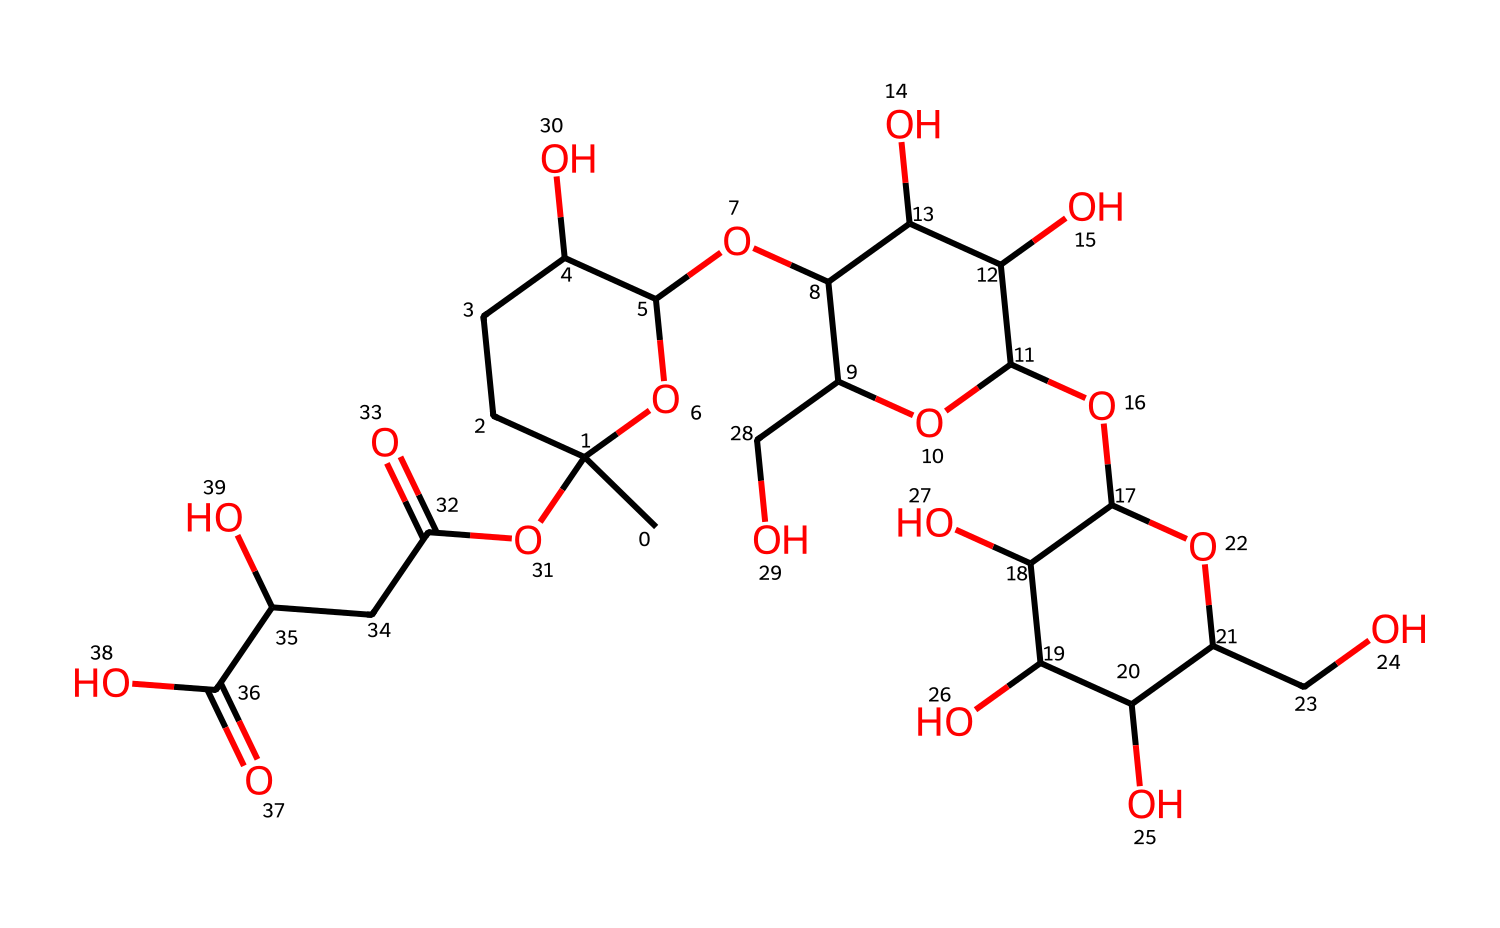What is the primary functional group present in xanthan gum? The structure of xanthan gum contains multiple hydroxyl (–OH) groups, which are indicative of its soluble and hydrophilic nature. These groups are responsible for the thickening properties of xanthan gum in gels.
Answer: hydroxyl group How many carbon atoms are in the structure of xanthan gum? By examining the SMILES representation, we can count the number of carbon atoms present. The formula indicates a total of 34 carbon atoms in the xanthan gum molecule.
Answer: 34 What type of polymer is xanthan gum classified as? Xanthan gum is a polysaccharide, as it is composed of multiple saccharide (sugar) units linked together. This classification is confirmed by the presence of the sugar rings in its structure.
Answer: polysaccharide How does xanthan gum behave in shear stress conditions? Xanthan gum is a non-Newtonian fluid, specifically a shear-thinning fluid, meaning its viscosity decreases under shear stress. This property is related to its polymeric structure and interactions between the molecules.
Answer: shear-thinning What is the main source from which xanthan gum is derived? Xanthan gum is primarily produced through the fermentation process of the bacterium Xanthomonas campestris. This is an important fact as it links its origin directly to biological sources.
Answer: Xanthomonas campestris 